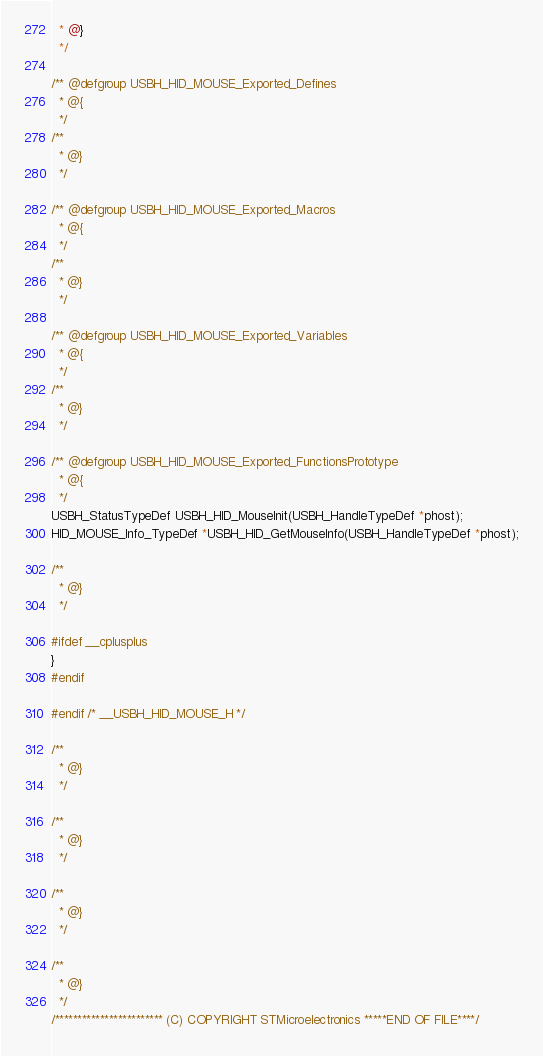Convert code to text. <code><loc_0><loc_0><loc_500><loc_500><_C_>  * @}
  */ 

/** @defgroup USBH_HID_MOUSE_Exported_Defines
  * @{
  */ 
/**
  * @}
  */ 

/** @defgroup USBH_HID_MOUSE_Exported_Macros
  * @{
  */ 
/**
  * @}
  */ 

/** @defgroup USBH_HID_MOUSE_Exported_Variables
  * @{
  */ 
/**
  * @}
  */ 

/** @defgroup USBH_HID_MOUSE_Exported_FunctionsPrototype
  * @{
  */ 
USBH_StatusTypeDef USBH_HID_MouseInit(USBH_HandleTypeDef *phost);
HID_MOUSE_Info_TypeDef *USBH_HID_GetMouseInfo(USBH_HandleTypeDef *phost);

/**
  * @}
  */ 

#ifdef __cplusplus
}
#endif

#endif /* __USBH_HID_MOUSE_H */

/**
  * @}
  */ 

/**
  * @}
  */ 

/**
  * @}
  */ 

/**
  * @}
  */ 
/************************ (C) COPYRIGHT STMicroelectronics *****END OF FILE****/
</code> 